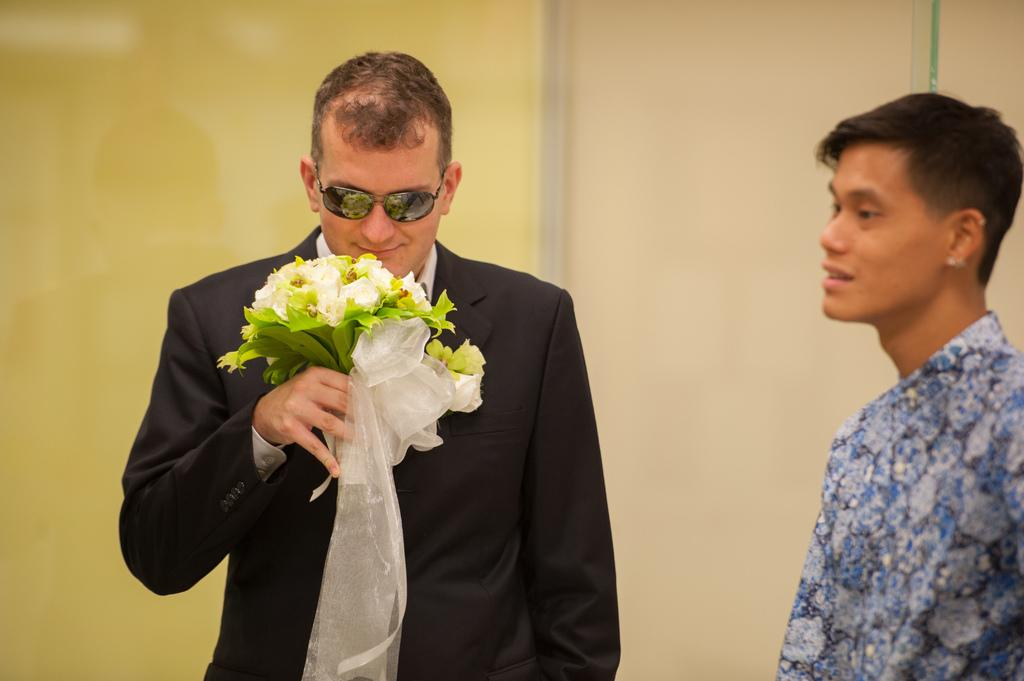What is the man in the image holding? The man is holding flowers in the image. Can you describe the other person in the image? There is another person in the image who is wearing a shirt. What type of support can be seen on the page in the image? There is no page or support present in the image; it only features a man holding flowers and another person wearing a shirt. 